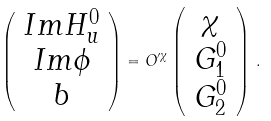<formula> <loc_0><loc_0><loc_500><loc_500>\left ( \begin{array} { c } I m H ^ { 0 } _ { u } \\ I m \phi \\ b \end{array} \right ) = O ^ { \prime \chi } \left ( \begin{array} { c } \chi \\ G ^ { 0 } _ { 1 } \\ G ^ { 0 } _ { 2 } \end{array} \right ) \, .</formula> 